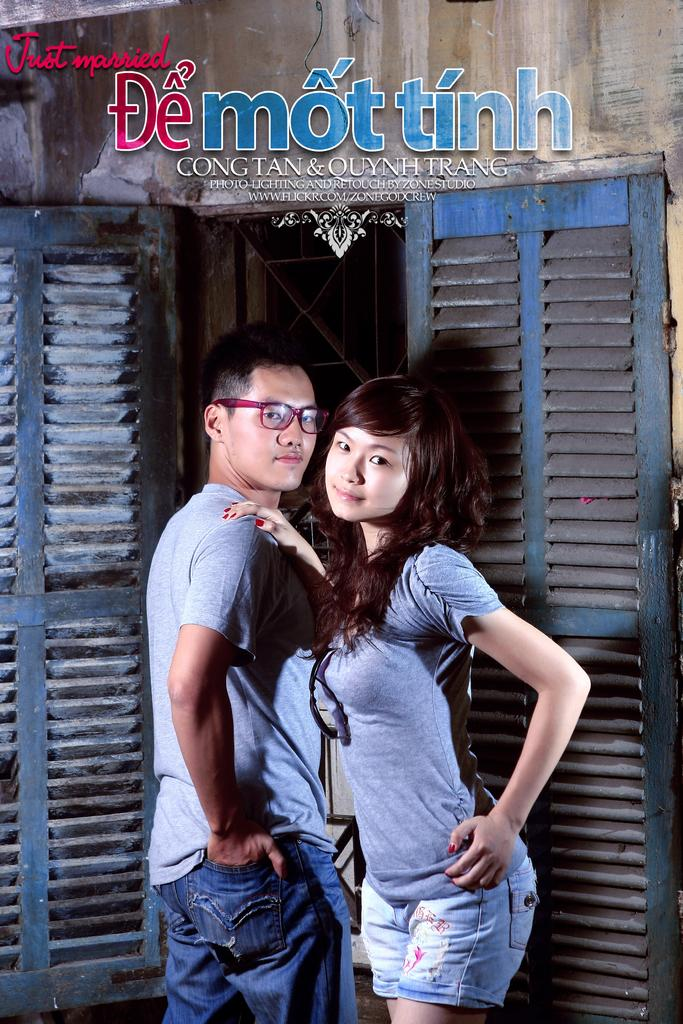Who are the people in the image? There is a man and a woman in the image. Where are the man and woman located in the image? The man and woman are standing in the middle of the image. What can be seen in the background of the image? There is a door in the background of the image. What is written or displayed at the top of the image? There is some text at the top of the image. What type of spark can be seen coming from the man's hand in the image? There is no spark present in the image; the man's hand is not shown producing any sparks. 